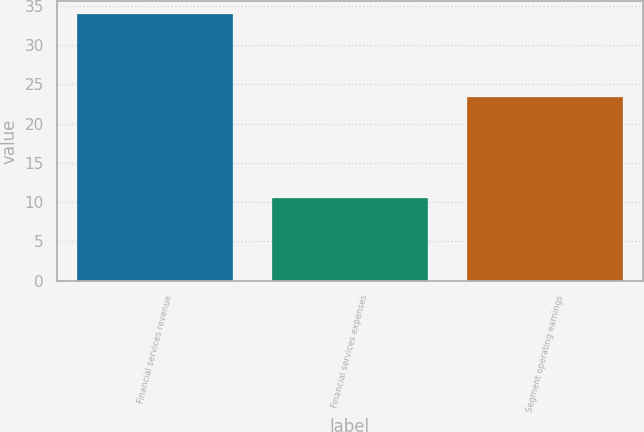<chart> <loc_0><loc_0><loc_500><loc_500><bar_chart><fcel>Financial services revenue<fcel>Financial services expenses<fcel>Segment operating earnings<nl><fcel>33.9<fcel>10.5<fcel>23.4<nl></chart> 